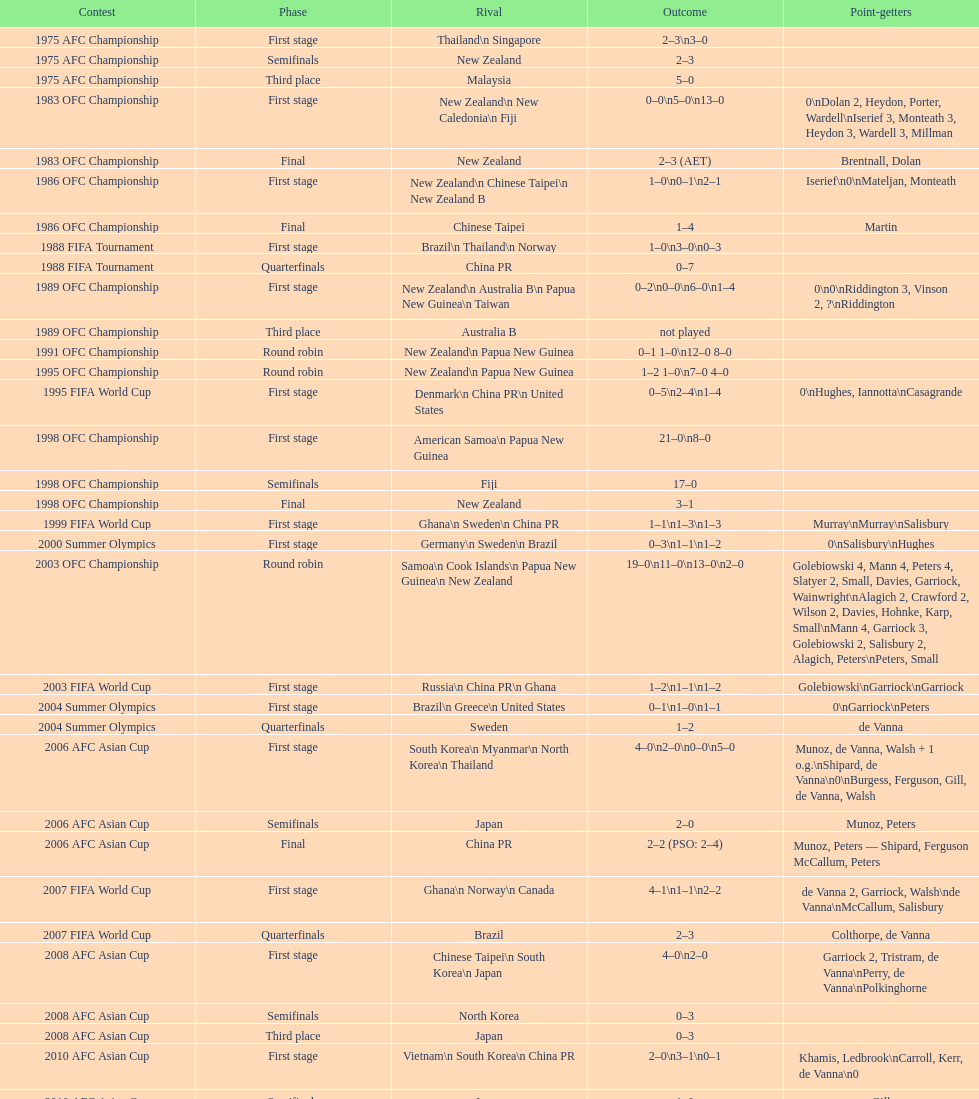How many points were scored in the final round of the 2012 summer olympics afc qualification? 12. 